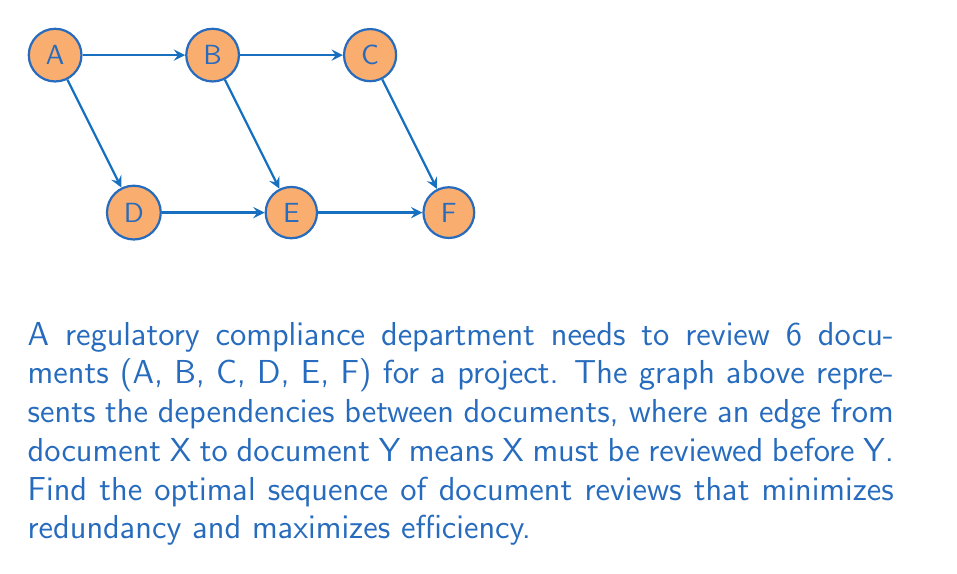Teach me how to tackle this problem. To find the optimal sequence, we'll use topological sorting, which is ideal for directed acyclic graphs (DAGs) like this one. The process is as follows:

1) Identify nodes with no incoming edges (sources):
   Only A has no incoming edges.

2) Remove A and its outgoing edges:
   [asy]
   unitsize(1cm);
   pair B = (2,2), C = (4,2), D = (1,0), E = (3,0), F = (5,0);
   dot("B", B, N);
   dot("C", C, N);
   dot("D", D, S);
   dot("E", E, S);
   dot("F", F, S);
   draw(B--C--F);
   draw(D--E--F);
   draw(B--E);
   [/asy]

3) Identify new sources:
   B and D are now sources.

4) Remove B and its edges:
   [asy]
   unitsize(1cm);
   pair C = (4,2), D = (1,0), E = (3,0), F = (5,0);
   dot("C", C, N);
   dot("D", D, S);
   dot("E", E, S);
   dot("F", F, S);
   draw(C--F);
   draw(D--E--F);
   [/asy]

5) Remove D and its edge:
   [asy]
   unitsize(1cm);
   pair C = (4,2), E = (3,0), F = (5,0);
   dot("C", C, N);
   dot("E", E, S);
   dot("F", F, S);
   draw(C--F);
   draw(E--F);
   [/asy]

6) Remove C and its edge:
   [asy]
   unitsize(1cm);
   pair E = (3,0), F = (5,0);
   dot("E", E, S);
   dot("F", F, S);
   draw(E--F);
   [/asy]

7) Remove E and its edge:
   [asy]
   unitsize(1cm);
   pair F = (5,0);
   dot("F", F, S);
   [/asy]

8) Remove F.

The order of removal gives us the optimal sequence: A, B, D, C, E, F.

This sequence ensures that each document is reviewed only after all its prerequisites have been reviewed, minimizing redundancy and maximizing efficiency.
Answer: A, B, D, C, E, F 